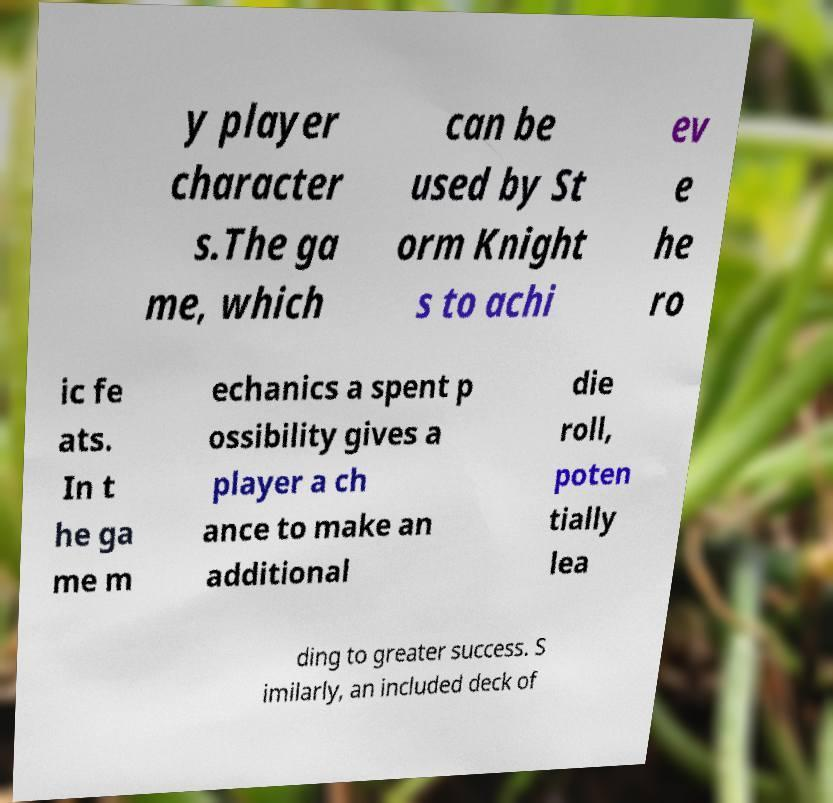Could you extract and type out the text from this image? y player character s.The ga me, which can be used by St orm Knight s to achi ev e he ro ic fe ats. In t he ga me m echanics a spent p ossibility gives a player a ch ance to make an additional die roll, poten tially lea ding to greater success. S imilarly, an included deck of 